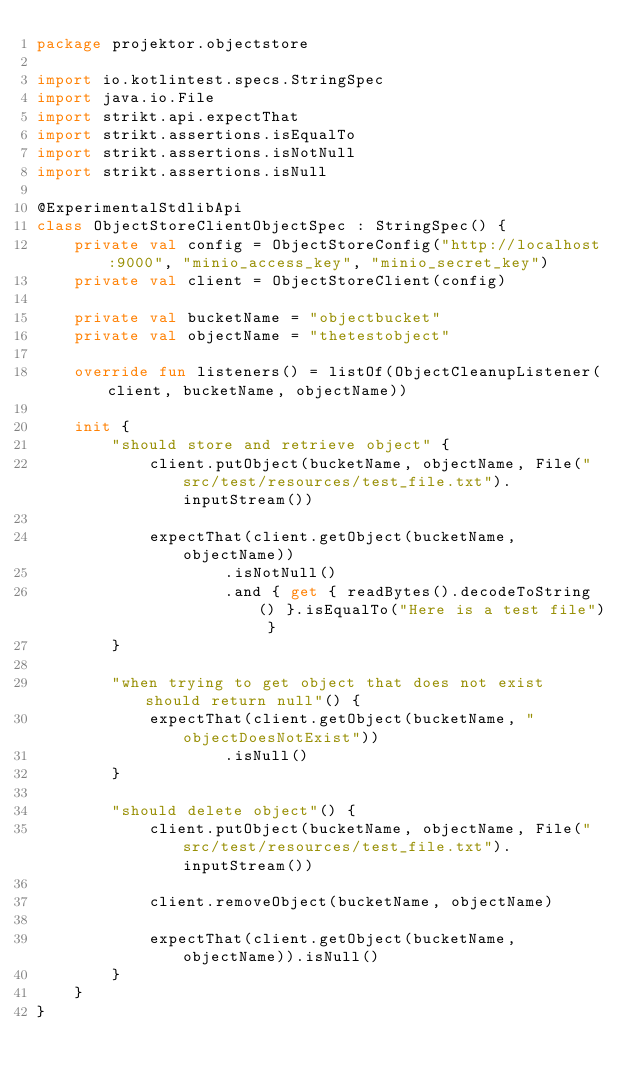Convert code to text. <code><loc_0><loc_0><loc_500><loc_500><_Kotlin_>package projektor.objectstore

import io.kotlintest.specs.StringSpec
import java.io.File
import strikt.api.expectThat
import strikt.assertions.isEqualTo
import strikt.assertions.isNotNull
import strikt.assertions.isNull

@ExperimentalStdlibApi
class ObjectStoreClientObjectSpec : StringSpec() {
    private val config = ObjectStoreConfig("http://localhost:9000", "minio_access_key", "minio_secret_key")
    private val client = ObjectStoreClient(config)

    private val bucketName = "objectbucket"
    private val objectName = "thetestobject"

    override fun listeners() = listOf(ObjectCleanupListener(client, bucketName, objectName))

    init {
        "should store and retrieve object" {
            client.putObject(bucketName, objectName, File("src/test/resources/test_file.txt").inputStream())

            expectThat(client.getObject(bucketName, objectName))
                    .isNotNull()
                    .and { get { readBytes().decodeToString() }.isEqualTo("Here is a test file") }
        }

        "when trying to get object that does not exist should return null"() {
            expectThat(client.getObject(bucketName, "objectDoesNotExist"))
                    .isNull()
        }

        "should delete object"() {
            client.putObject(bucketName, objectName, File("src/test/resources/test_file.txt").inputStream())

            client.removeObject(bucketName, objectName)

            expectThat(client.getObject(bucketName, objectName)).isNull()
        }
    }
}
</code> 